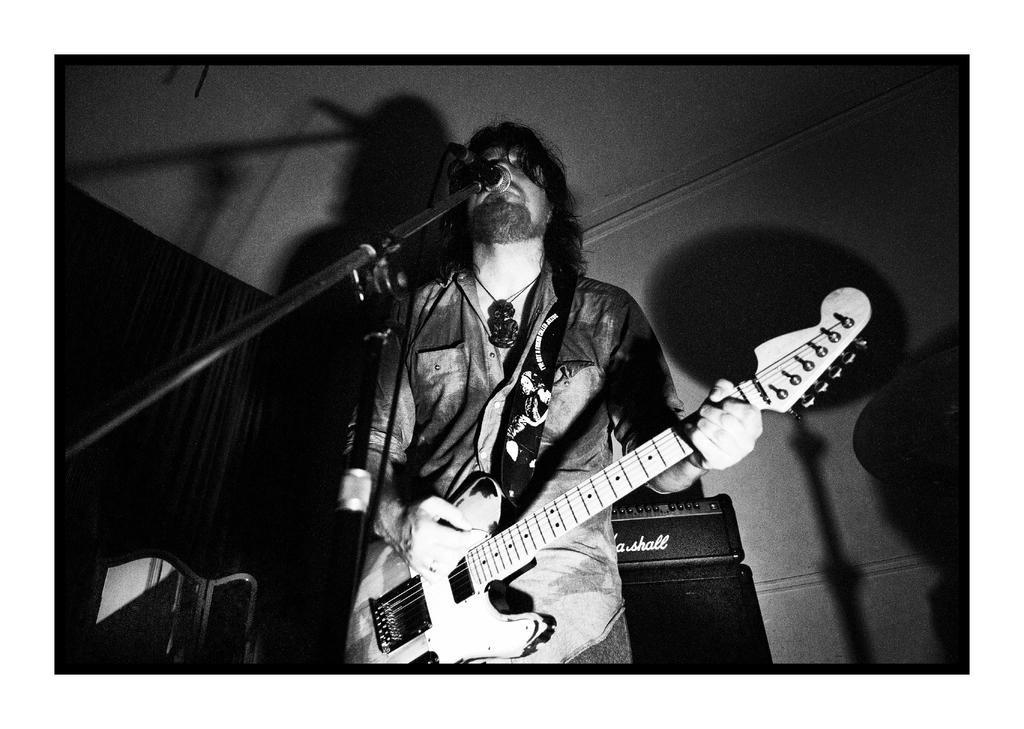What is the man in the image doing? The man is playing a guitar. How is the man holding the guitar? The man is holding the guitar in his hands. What is the purpose of the microphone in the image? The microphone is on a stand, likely for amplifying the man's voice while he plays the guitar. What can be seen in the background of the image? There is a wall in the background of the image. What type of substance is the man using to teach the tin in the image? There is no substance or tin present in the image; it features a man playing a guitar and a microphone on a stand. 